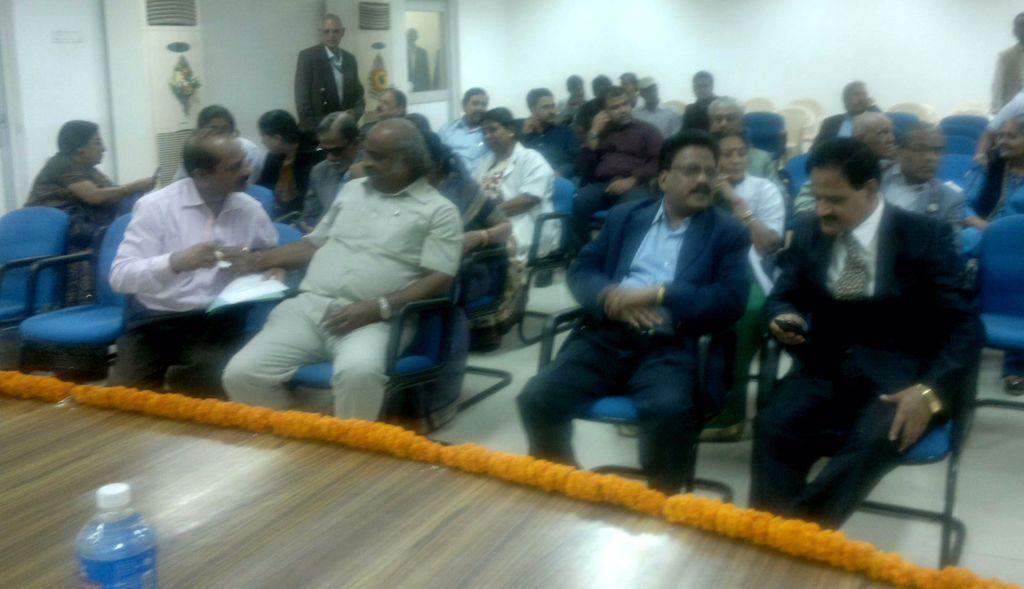Can you describe this image briefly? On the left side, there is a bottle. On the right side, there is a flower wreath on a stage. In the background, there are persons sitting on chairs, there are persons standing, there are machines and there is a white wall. 